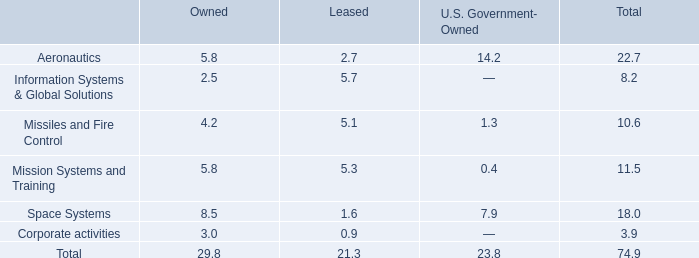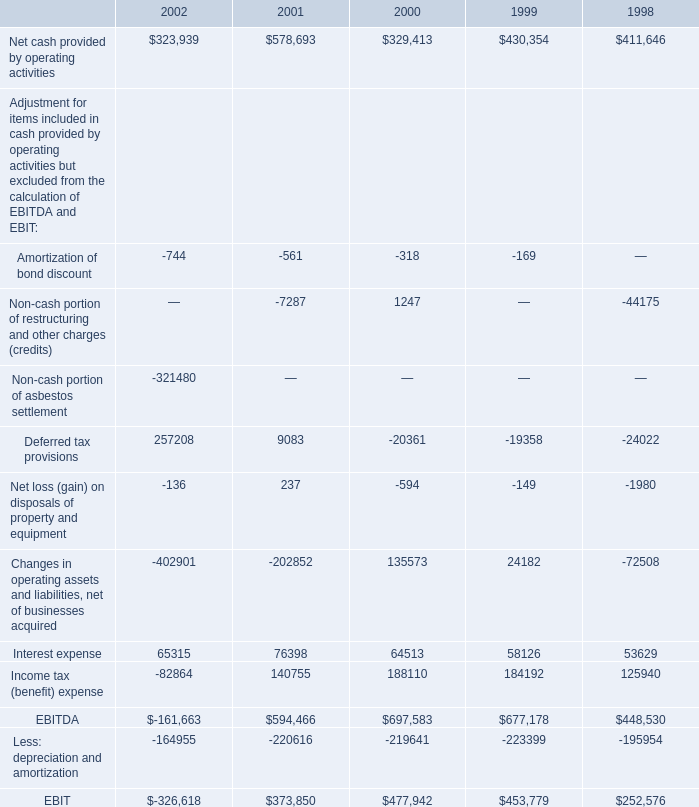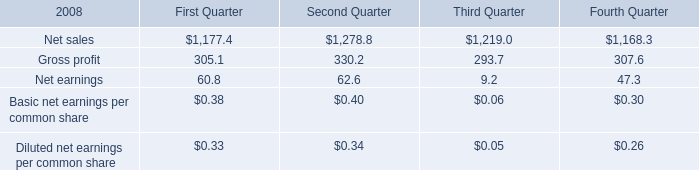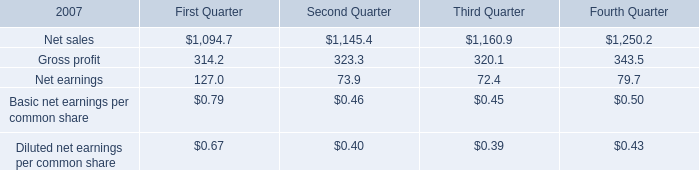As As the chart 1 shows,in the year where Interest expense is the highest, what's the growth rate of EBITDA? 
Computations: ((594466 - 697583) / 697583)
Answer: -0.14782. What's the average of Net cash provided by operating activities of 2002, and Net sales of Third Quarter ? 
Computations: ((323939.0 + 1160.9) / 2)
Answer: 162549.95. 